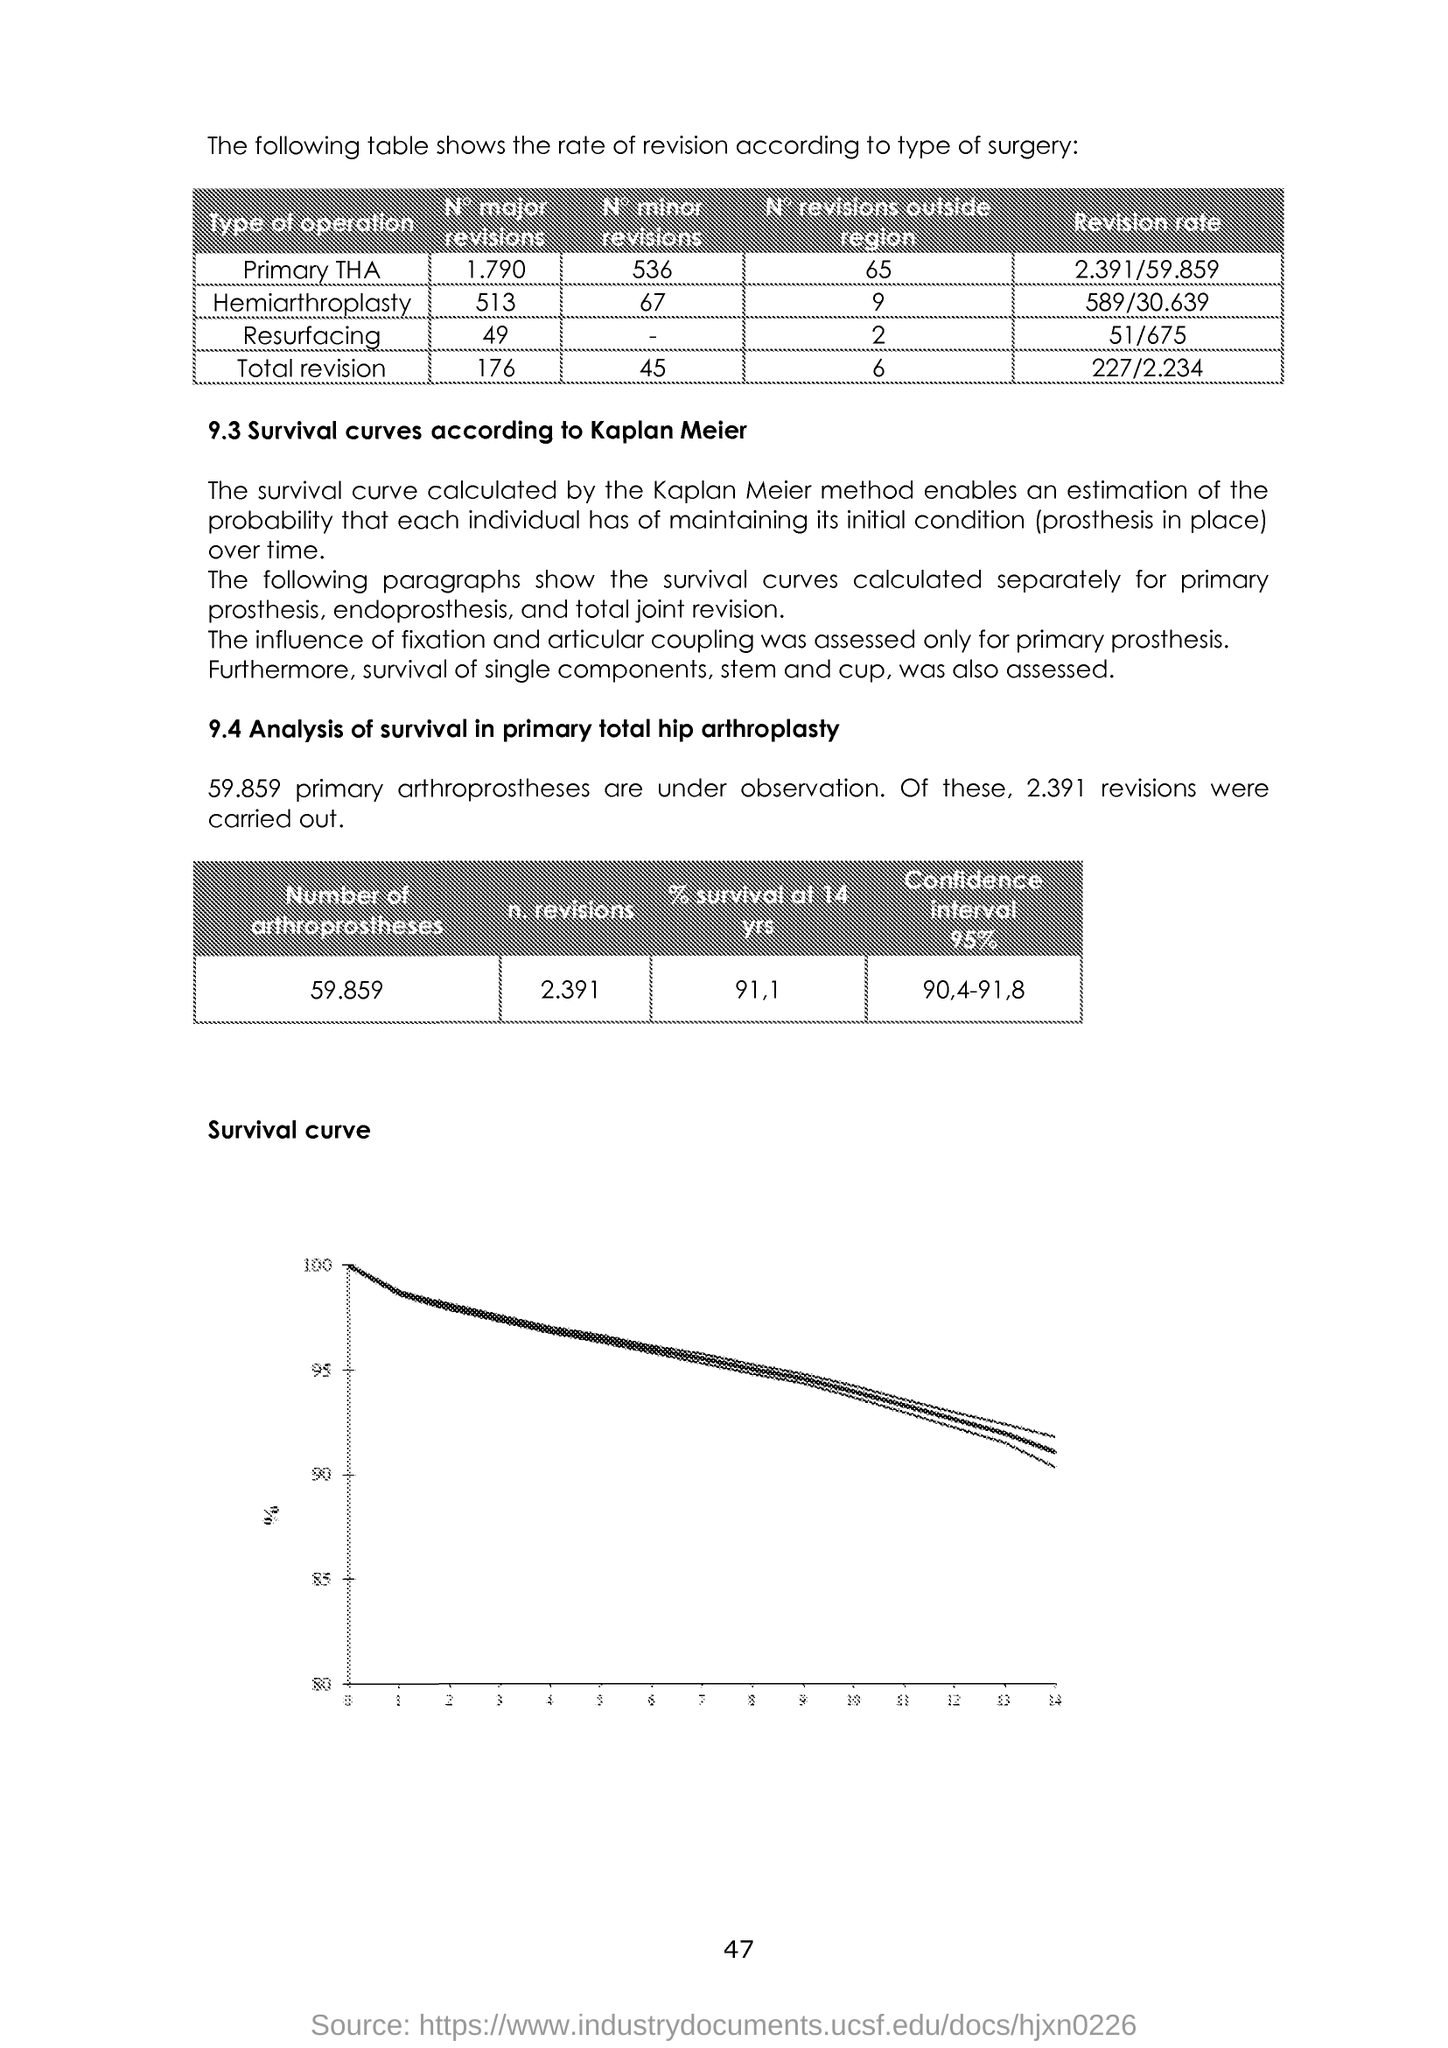What is the number of revisions carried out in the analysis?
Your response must be concise. 2.391. What is the % survival at 14 yrs?
Offer a very short reply. 91,1. What is the title of the graph shown?
Keep it short and to the point. Survival curve. Why was the influence of fixation and articular coupling assessed?
Provide a short and direct response. Only for primary prosthesis. What is the revision rate for Primary THA as given in the table?
Your answer should be compact. 2 391/59 859. What is the revision rate for Resurfacing as given in the table?
Give a very brief answer. 51/675. 